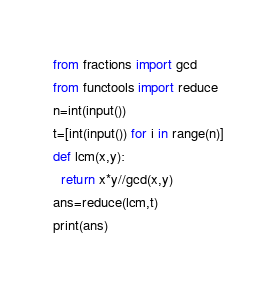<code> <loc_0><loc_0><loc_500><loc_500><_Python_>from fractions import gcd
from functools import reduce
n=int(input())
t=[int(input()) for i in range(n)]
def lcm(x,y):
  return x*y//gcd(x,y)
ans=reduce(lcm,t)
print(ans)</code> 